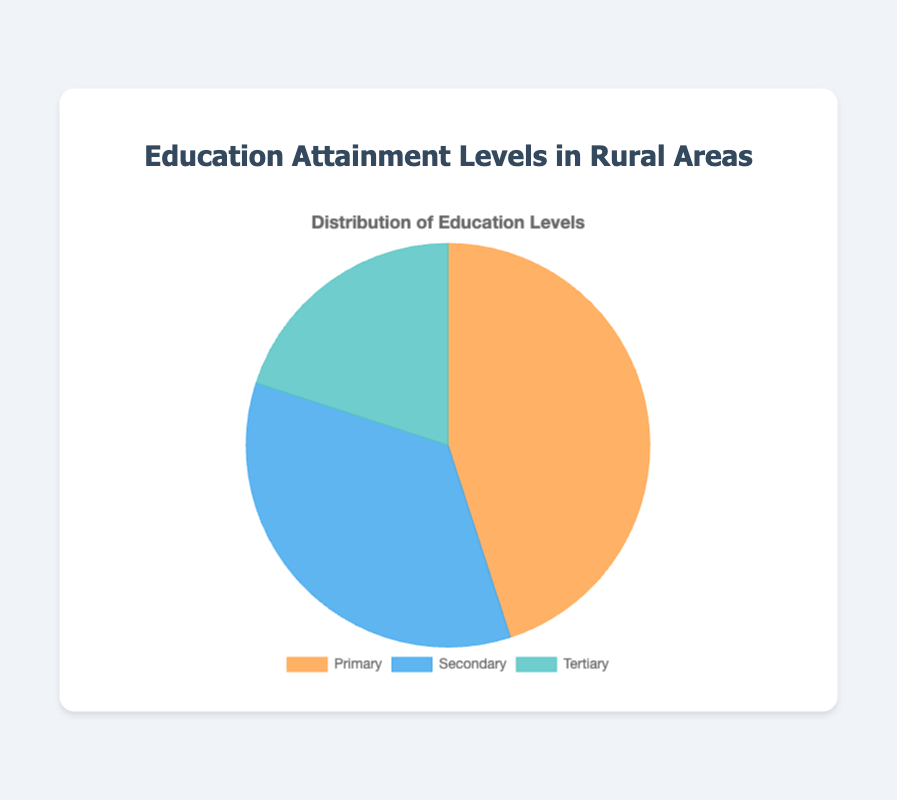What percentage of people have secondary education? The pie chart shows the education attainment levels with 'Secondary' indicated as one of the segments. The percentage for 'Secondary' is provided directly in the chart.
Answer: 35% How many more people have primary education compared to tertiary education? The chart shows that 45% of people have primary education while 20% have tertiary education. The difference is 45% - 20% = 25%.
Answer: 25% What proportion of people have at least secondary education? To find the proportion, sum up the percentages of people with secondary and tertiary education. That is 35% (secondary) + 20% (tertiary) = 55%.
Answer: 55% Of all the education levels, which one has the smallest proportion? By observing the pie chart, 'Tertiary' has the smallest segment among the three categories. The percentage for tertiary education is 20%, which is the smallest.
Answer: Tertiary How does the proportion of primary education compare to secondary education? The percentage of primary education (45%) is compared to secondary education (35%). The former is higher.
Answer: Primary is higher If the population is 1000 people, how many people have tertiary education? To find the number of people, multiply the total population by the percentage for tertiary education. That is 1000 * 20% = 200 people.
Answer: 200 Which education level is represented by the orange color in the chart? The pie chart uses specific colors for each segment. The orange color corresponds to the 'Primary' segment.
Answer: Primary What fraction of the population has primary education? The percentage of people with primary education is 45%. As a fraction, this percentage is 45/100, which simplifies to 9/20.
Answer: 9/20 Is the percentage of people with secondary education more than double that of tertiary education? The percentage for secondary education is 35% and for tertiary education is 20%. Doubling 20% gives 40%. Since 35% is less than 40%, the percentage of secondary education is not more than double that of tertiary education.
Answer: No 